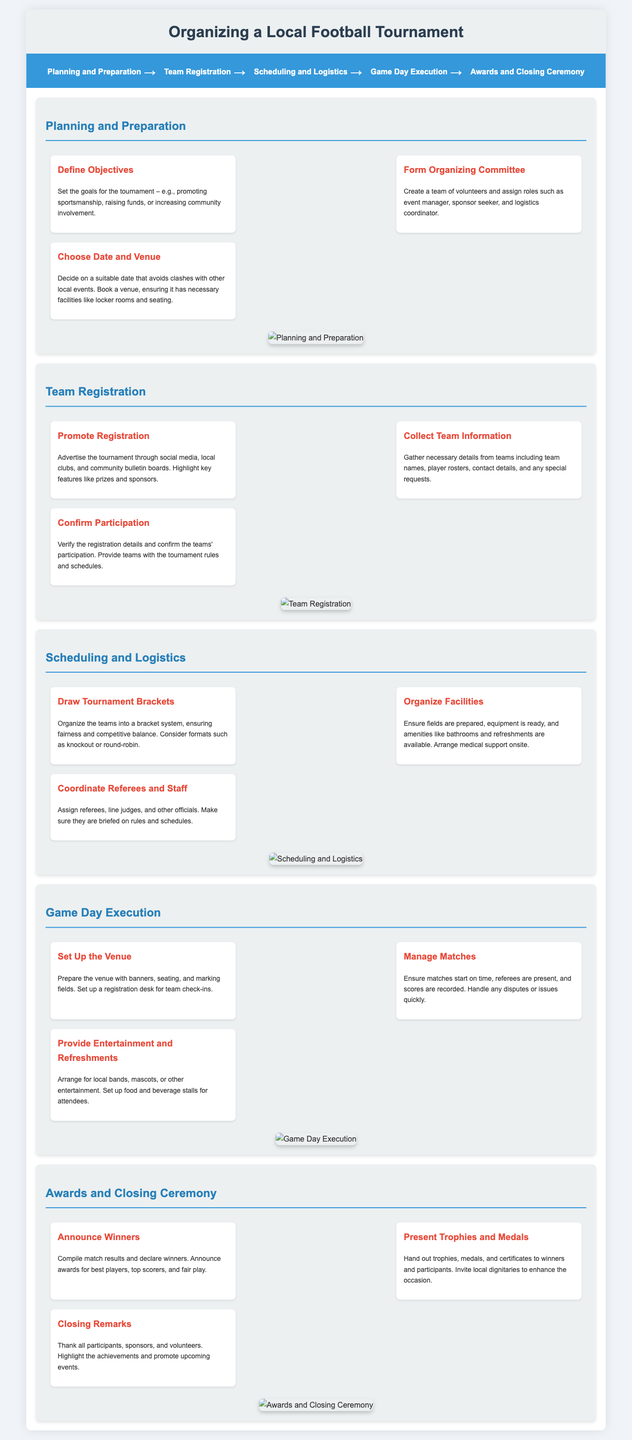What is the first step in organizing a tournament? The first step is "Planning and Preparation" as indicated in the process flow.
Answer: Planning and Preparation How many sub-steps are included in the Team Registration section? There are three sub-steps outlined in the Team Registration section.
Answer: Three What should be set up at the venue on Game Day? The venue should be prepared with banners, seating, and marked fields as mentioned in the Game Day Execution section.
Answer: Banners, seating, and marked fields What is one of the objectives that can be set for the tournament? One possible objective mentioned is "promoting sportsmanship."
Answer: Promoting sportsmanship Who may attend the trophy presentation? Local dignitaries may be invited to enhance the occasion during the awards and closing ceremony.
Answer: Local dignitaries Which section discusses coordinating referees and staff? The section that discusses this is "Scheduling and Logistics."
Answer: Scheduling and Logistics How should teams confirm their participation? Teams confirm their participation by verifying their registration details as stated in the Team Registration section.
Answer: Verifying registration details What is one of the prizes mentioned for the tournament? Awards for "best players" are mentioned as one of the prizes.
Answer: Best players In which step is medical support arranged? Medical support is arranged in the "Organize Facilities" sub-step.
Answer: Organize Facilities 